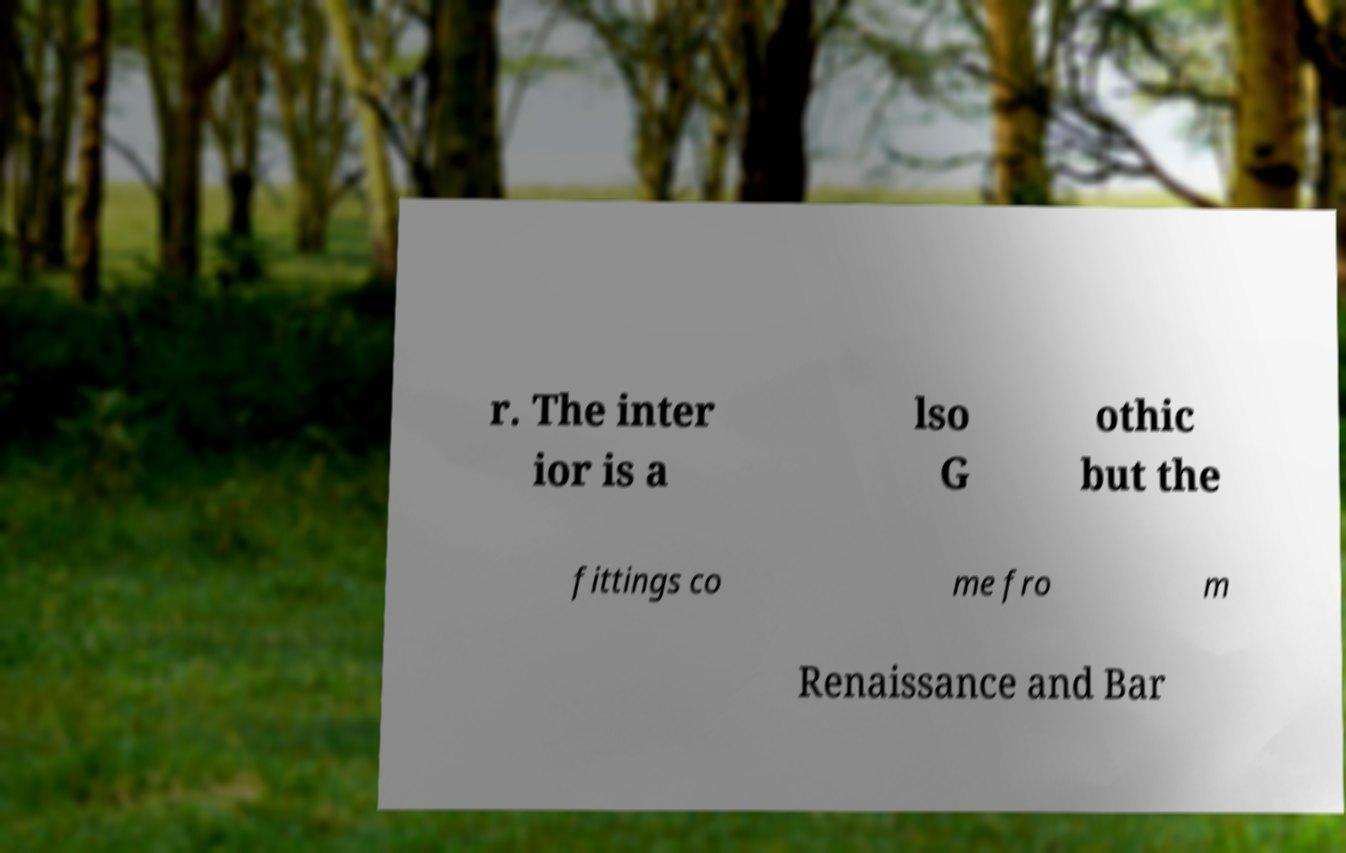There's text embedded in this image that I need extracted. Can you transcribe it verbatim? r. The inter ior is a lso G othic but the fittings co me fro m Renaissance and Bar 